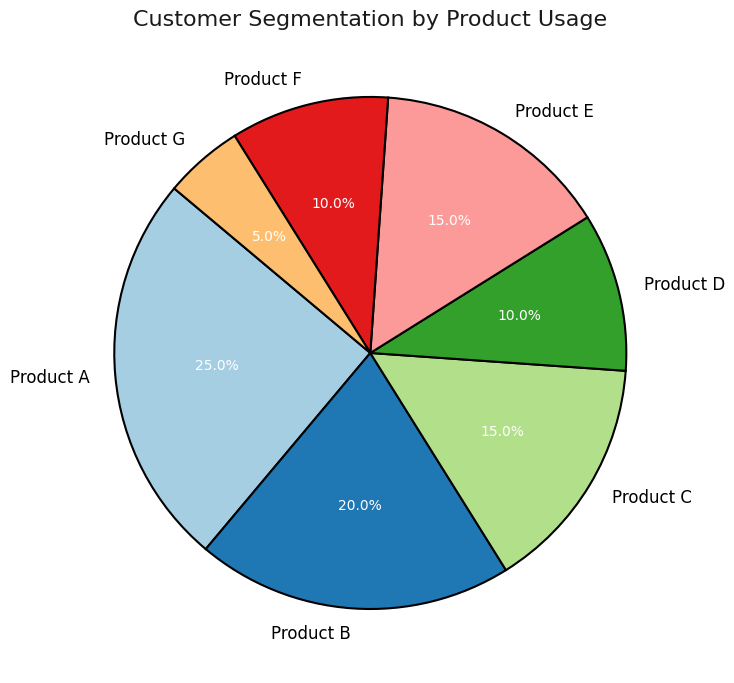What's the combined usage percentage of Products A and B? Products A and B have usage percentages of 25% and 20% respectively. Adding them together: 25% + 20% = 45%.
Answer: 45% Which product segment has the lowest usage percentage? On the pie chart, Product G has the smallest slice, with a usage percentage of 5%.
Answer: Product G Which products together account for 30% of usage? Products D and F each have usage percentages of 10%, together making 10% + 10% = 20%. Adding Product G's 5% makes it 25%, and adding 5% from any 15% segment (Product C or E) finishes the 30%.
Answer: Products D, F, and half of C or E What is the difference between the highest and lowest usage percentages? Product A has the highest usage percentage at 25%, and Product G has the lowest at 5%. The difference is 25% - 5% = 20%.
Answer: 20% Are there any products with the same usage percentage? Yes, Products C and E each have a usage percentage of 15%, and Products D and F each have a usage percentage of 10%.
Answer: Yes What percentage of usage do Products C, D, and E collectively contribute? Adding the usage percentages: Product C (15%) + Product D (10%) + Product E (15%) gives 15% + 10% + 15% = 40%.
Answer: 40% How does the usage percentage of Product B compare to that of Product F? The pie chart shows Product B with 20% usage and Product F with 10% usage. Thus, Product B's usage is greater.
Answer: Product B's usage is greater Which segment's slice in the pie chart is visually the most similar in size to Product C's slice? Product E has the same usage percentage as Product C at 15%, resulting in similar-sized slices.
Answer: Product E What is the total usage percentage of all products except Product A? Subtracting Product A's percentage from 100%: 100% - 25% = 75%.
Answer: 75% Compare the total usage percentages of Products A and D combined to the total of Products C and F combined. Which is higher? Products A and D have a combined usage of 25% + 10% = 35%. Products C and F have 15% + 10% = 25%. Therefore, the A and D combination is higher.
Answer: Products A and D 